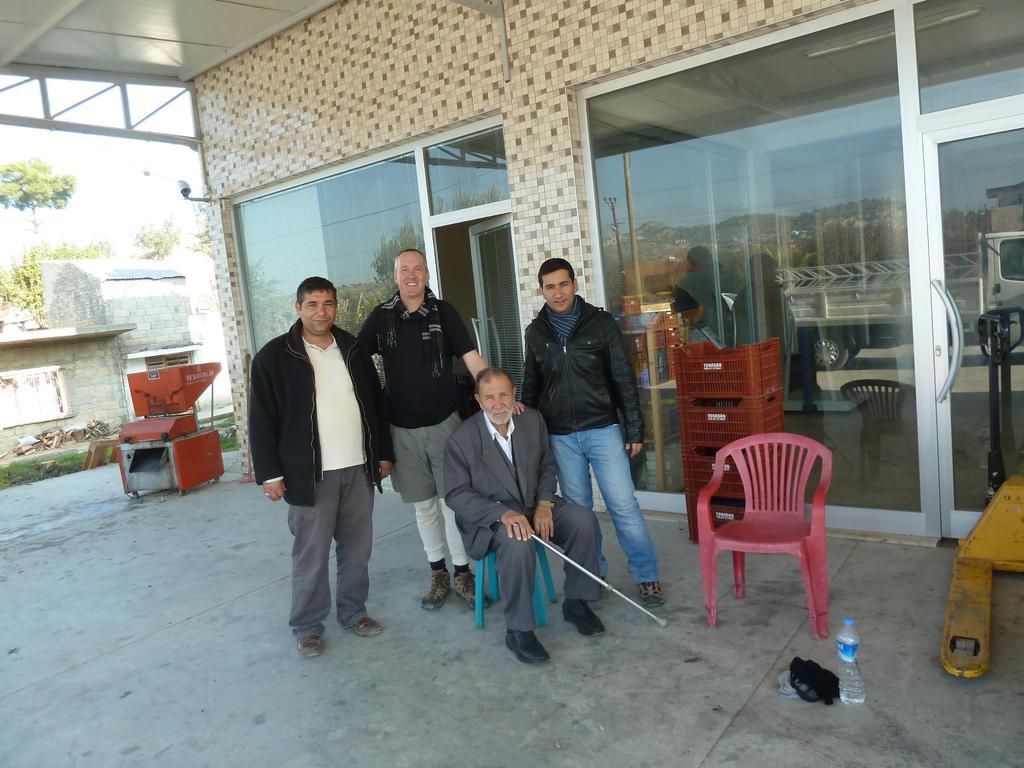Could you give a brief overview of what you see in this image? In this image I can see four people. At the back of them there is a building and a machine. There are some trees and the sky. 